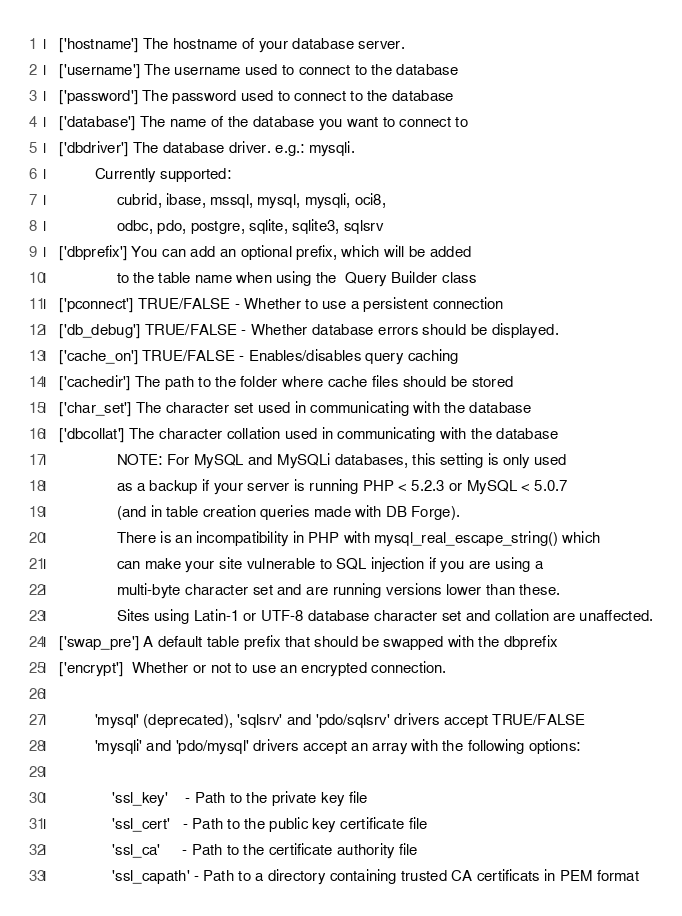<code> <loc_0><loc_0><loc_500><loc_500><_PHP_>|	['hostname'] The hostname of your database server.
|	['username'] The username used to connect to the database
|	['password'] The password used to connect to the database
|	['database'] The name of the database you want to connect to
|	['dbdriver'] The database driver. e.g.: mysqli.
|			Currently supported:
|				 cubrid, ibase, mssql, mysql, mysqli, oci8,
|				 odbc, pdo, postgre, sqlite, sqlite3, sqlsrv
|	['dbprefix'] You can add an optional prefix, which will be added
|				 to the table name when using the  Query Builder class
|	['pconnect'] TRUE/FALSE - Whether to use a persistent connection
|	['db_debug'] TRUE/FALSE - Whether database errors should be displayed.
|	['cache_on'] TRUE/FALSE - Enables/disables query caching
|	['cachedir'] The path to the folder where cache files should be stored
|	['char_set'] The character set used in communicating with the database
|	['dbcollat'] The character collation used in communicating with the database
|				 NOTE: For MySQL and MySQLi databases, this setting is only used
| 				 as a backup if your server is running PHP < 5.2.3 or MySQL < 5.0.7
|				 (and in table creation queries made with DB Forge).
| 				 There is an incompatibility in PHP with mysql_real_escape_string() which
| 				 can make your site vulnerable to SQL injection if you are using a
| 				 multi-byte character set and are running versions lower than these.
| 				 Sites using Latin-1 or UTF-8 database character set and collation are unaffected.
|	['swap_pre'] A default table prefix that should be swapped with the dbprefix
|	['encrypt']  Whether or not to use an encrypted connection.
|
|			'mysql' (deprecated), 'sqlsrv' and 'pdo/sqlsrv' drivers accept TRUE/FALSE
|			'mysqli' and 'pdo/mysql' drivers accept an array with the following options:
|
|				'ssl_key'    - Path to the private key file
|				'ssl_cert'   - Path to the public key certificate file
|				'ssl_ca'     - Path to the certificate authority file
|				'ssl_capath' - Path to a directory containing trusted CA certificats in PEM format</code> 